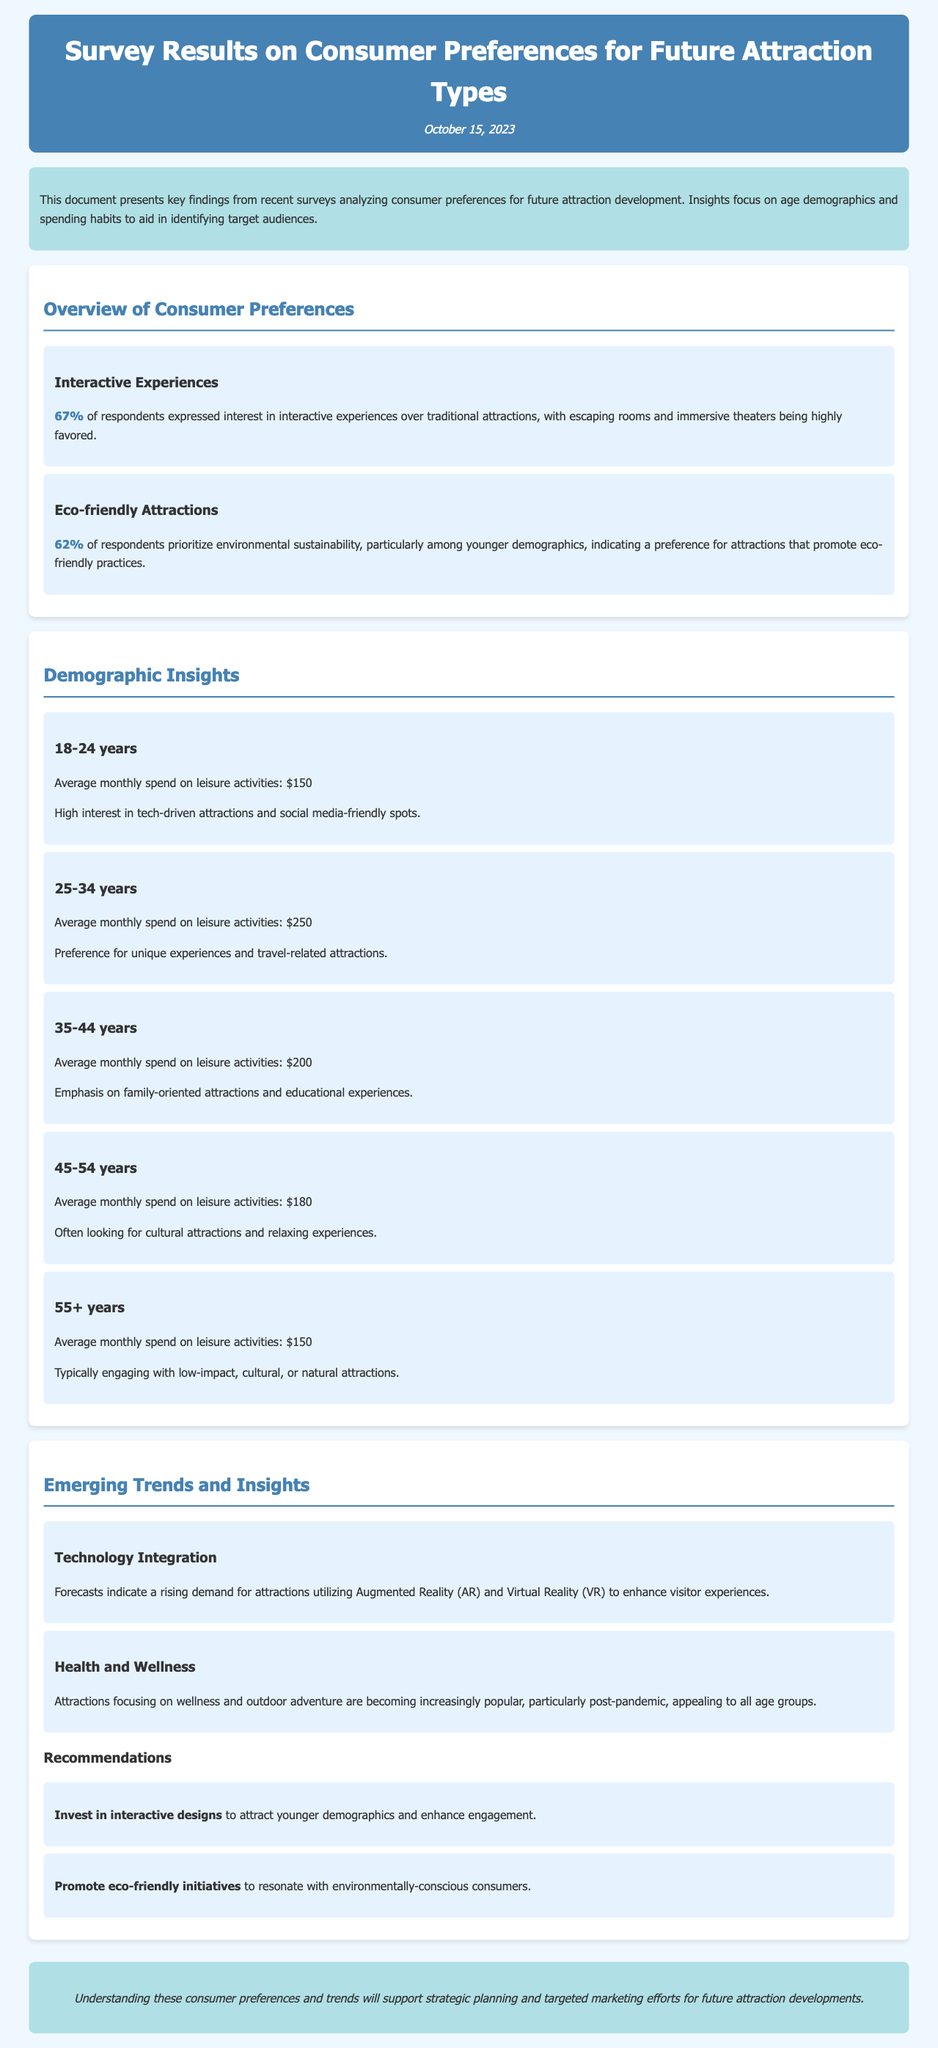What percentage of respondents prefer interactive experiences? The document states that 67% of respondents expressed interest in interactive experiences over traditional attractions.
Answer: 67% What is the average monthly spend on leisure activities for the 25-34 age group? The document specifies that the average monthly spend on leisure activities for the 25-34 years age group is $250.
Answer: $250 Which age group has the highest average monthly spending on leisure activities? Based on the document, the 25-34 years age group has the highest average monthly spending at $250.
Answer: 25-34 years What is a key finding related to eco-friendly attractions? The document indicates that 62% of respondents prioritize environmental sustainability, particularly among younger demographics.
Answer: 62% What emerging trend is mentioned regarding technology in attractions? The document forecasts a rising demand for attractions utilizing Augmented Reality (AR) and Virtual Reality (VR) to enhance visitor experiences.
Answer: AR and VR What type of attractions are appealing to all age groups post-pandemic? The document mentions that attractions focusing on wellness and outdoor adventure are becoming popular across all age groups.
Answer: Wellness and outdoor adventure What is recommended to resonate with environmentally-conscious consumers? The document suggests promoting eco-friendly initiatives to appeal to consumers who value sustainability.
Answer: Promote eco-friendly initiatives In what format is the document presented? The document is structured as a report focusing on survey results related to consumer preferences for future attraction types.
Answer: Report 